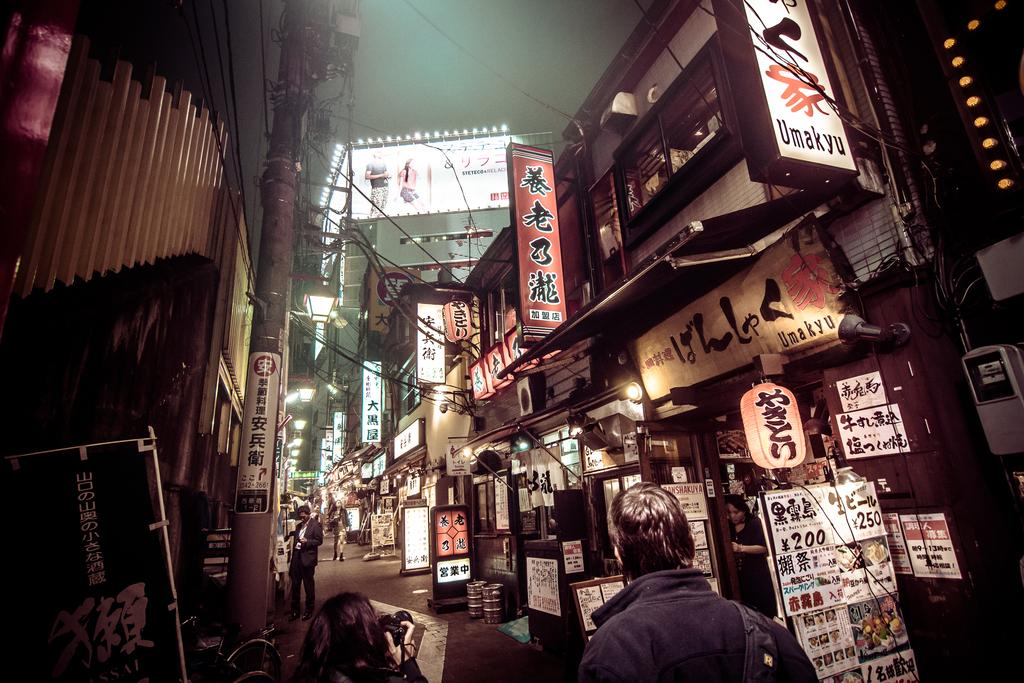What is visible at the top of the image? The sky is visible at the top of the image. What can be seen on either side of the road in the image? There are buildings and hoardings on either side of the road. Are there any people in the image? Yes, people are present on the road. Can you see a jar filled with fish in the image? No, there is no jar filled with fish present in the image. Is there a carpenter working on the road in the image? No, there is no carpenter present in the image. 